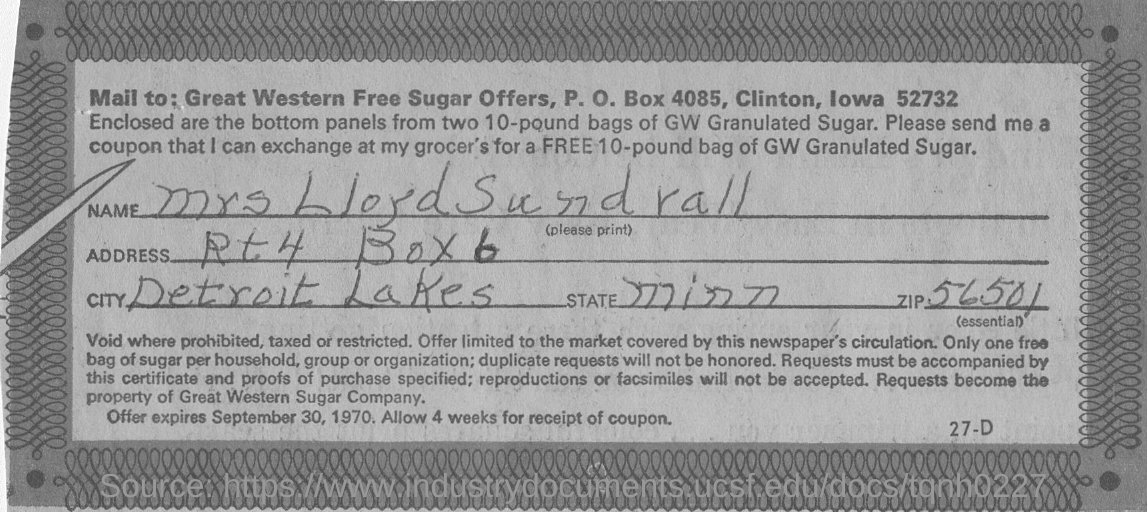Outline some significant characteristics in this image. The name written is "Mrs LloydSundrall. 